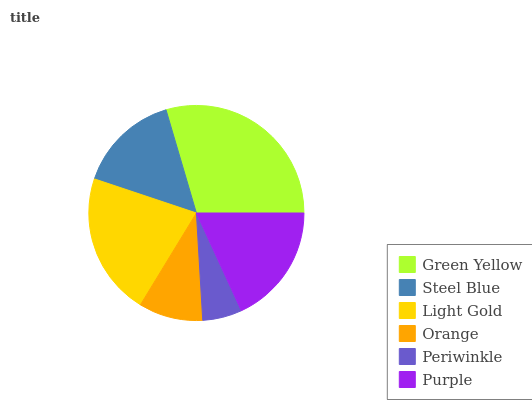Is Periwinkle the minimum?
Answer yes or no. Yes. Is Green Yellow the maximum?
Answer yes or no. Yes. Is Steel Blue the minimum?
Answer yes or no. No. Is Steel Blue the maximum?
Answer yes or no. No. Is Green Yellow greater than Steel Blue?
Answer yes or no. Yes. Is Steel Blue less than Green Yellow?
Answer yes or no. Yes. Is Steel Blue greater than Green Yellow?
Answer yes or no. No. Is Green Yellow less than Steel Blue?
Answer yes or no. No. Is Purple the high median?
Answer yes or no. Yes. Is Steel Blue the low median?
Answer yes or no. Yes. Is Light Gold the high median?
Answer yes or no. No. Is Orange the low median?
Answer yes or no. No. 